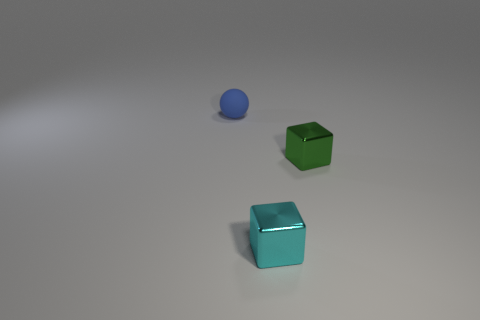The thing that is both behind the small cyan cube and on the left side of the small green metal thing has what shape?
Offer a terse response. Sphere. Are there more blocks to the right of the small blue sphere than tiny metal things that are behind the cyan object?
Make the answer very short. Yes. Are there any objects left of the green thing?
Your answer should be compact. Yes. Are there any green metallic things that have the same size as the cyan thing?
Keep it short and to the point. Yes. There is a object that is the same material as the cyan cube; what is its color?
Ensure brevity in your answer.  Green. What is the material of the ball?
Ensure brevity in your answer.  Rubber. What is the shape of the tiny blue rubber thing?
Offer a terse response. Sphere. What number of tiny shiny blocks are the same color as the tiny rubber object?
Your answer should be very brief. 0. What material is the object that is behind the tiny metal object that is on the right side of the shiny thing in front of the green cube?
Keep it short and to the point. Rubber. What number of green objects are tiny metal blocks or tiny objects?
Offer a very short reply. 1. 